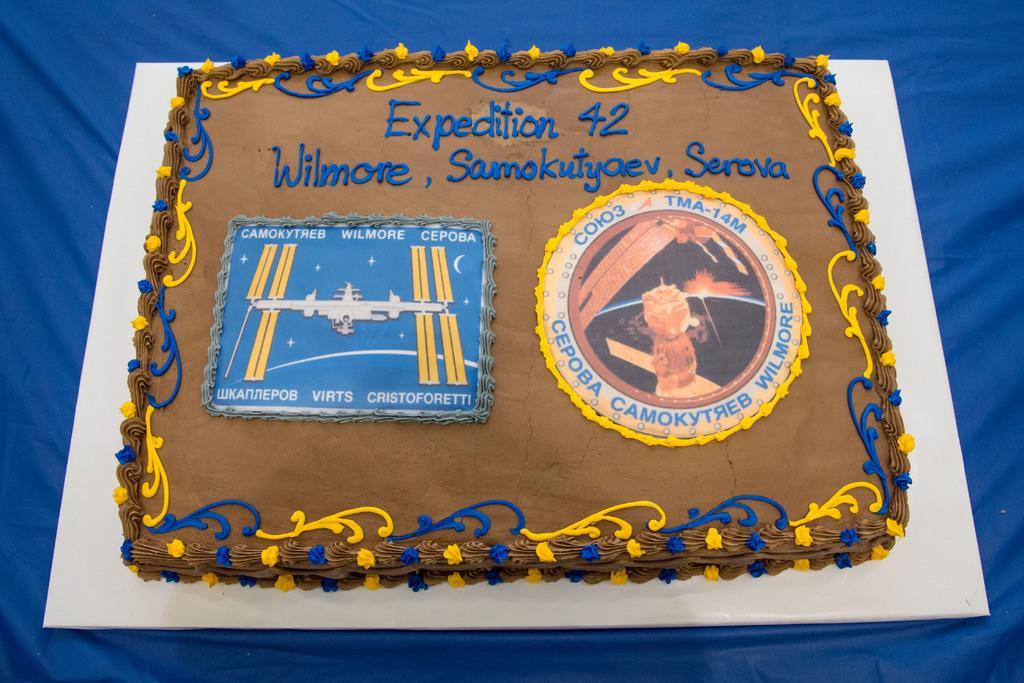Please provide a concise description of this image. In this image I can see a cake, on the blue color cloth and the cake is in brown color. I can see something written on the cake. 